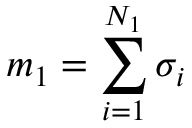<formula> <loc_0><loc_0><loc_500><loc_500>m _ { 1 } = \sum _ { i = 1 } ^ { N _ { 1 } } \sigma _ { i }</formula> 